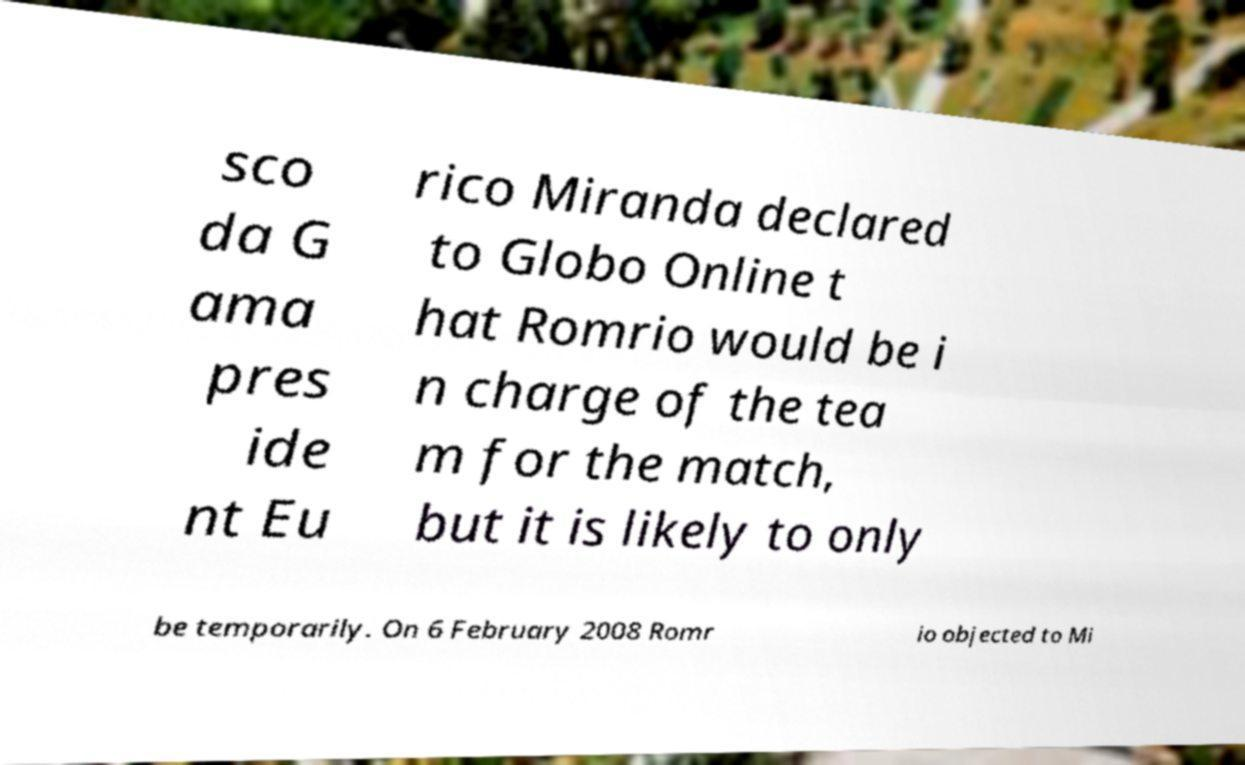I need the written content from this picture converted into text. Can you do that? sco da G ama pres ide nt Eu rico Miranda declared to Globo Online t hat Romrio would be i n charge of the tea m for the match, but it is likely to only be temporarily. On 6 February 2008 Romr io objected to Mi 